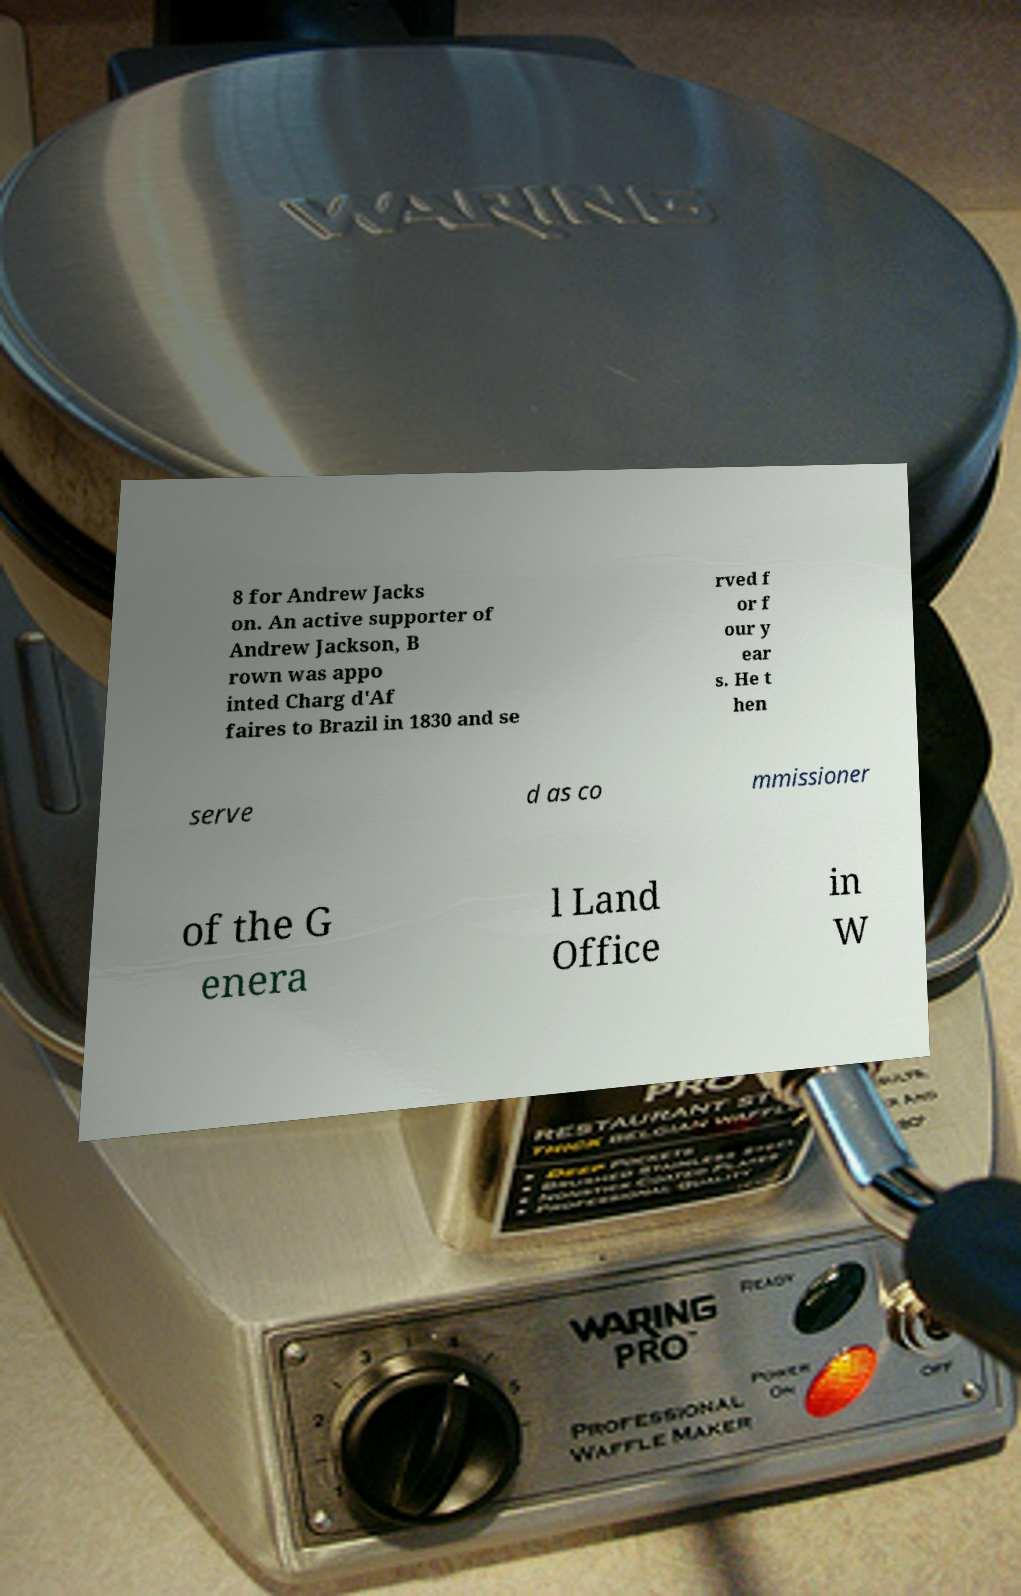Please identify and transcribe the text found in this image. 8 for Andrew Jacks on. An active supporter of Andrew Jackson, B rown was appo inted Charg d'Af faires to Brazil in 1830 and se rved f or f our y ear s. He t hen serve d as co mmissioner of the G enera l Land Office in W 